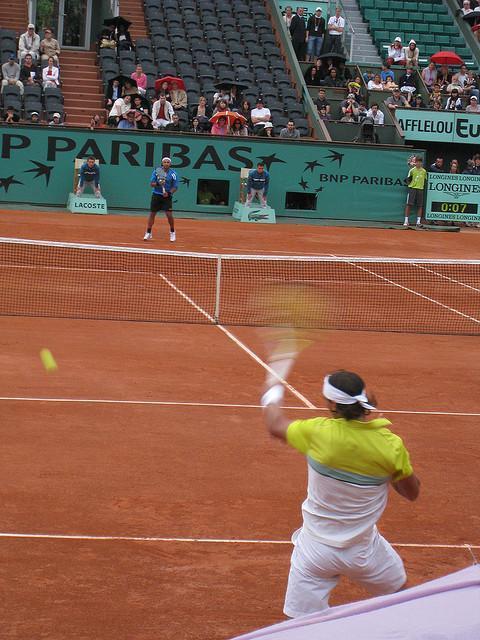How many people are visible?
Give a very brief answer. 2. How many birds have red on their head?
Give a very brief answer. 0. 